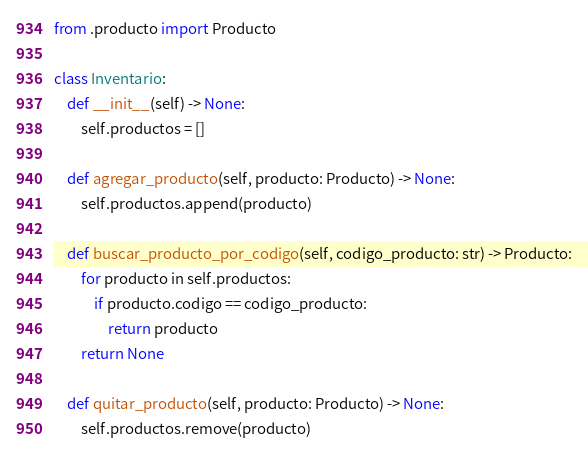<code> <loc_0><loc_0><loc_500><loc_500><_Python_>from .producto import Producto

class Inventario:
    def __init__(self) -> None:
        self.productos = []

    def agregar_producto(self, producto: Producto) -> None:
        self.productos.append(producto)

    def buscar_producto_por_codigo(self, codigo_producto: str) -> Producto:
        for producto in self.productos:
            if producto.codigo == codigo_producto:
                return producto
        return None

    def quitar_producto(self, producto: Producto) -> None:
        self.productos.remove(producto)</code> 